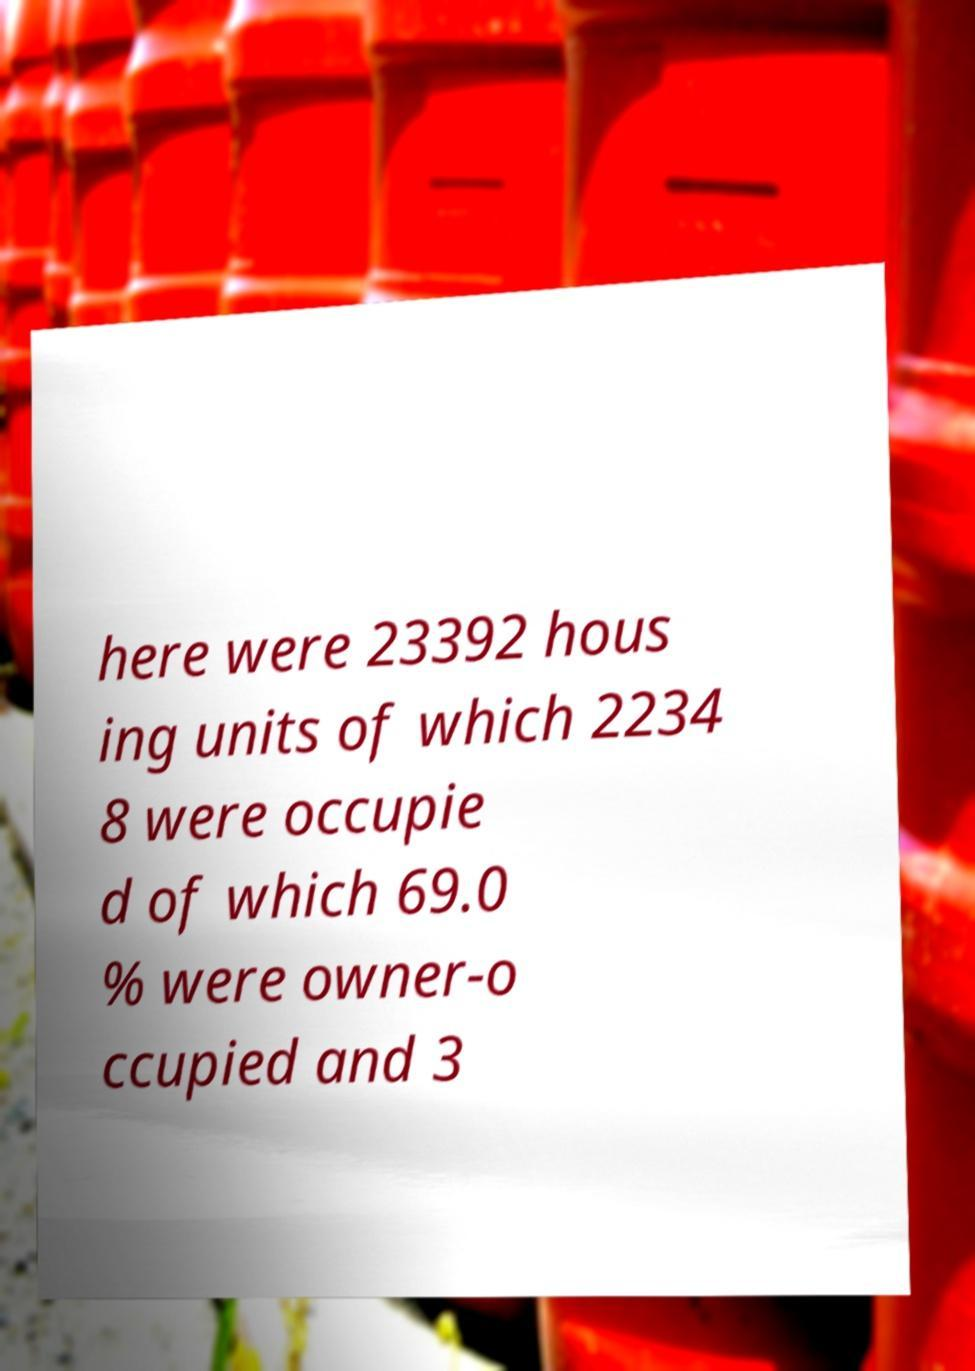Could you assist in decoding the text presented in this image and type it out clearly? here were 23392 hous ing units of which 2234 8 were occupie d of which 69.0 % were owner-o ccupied and 3 